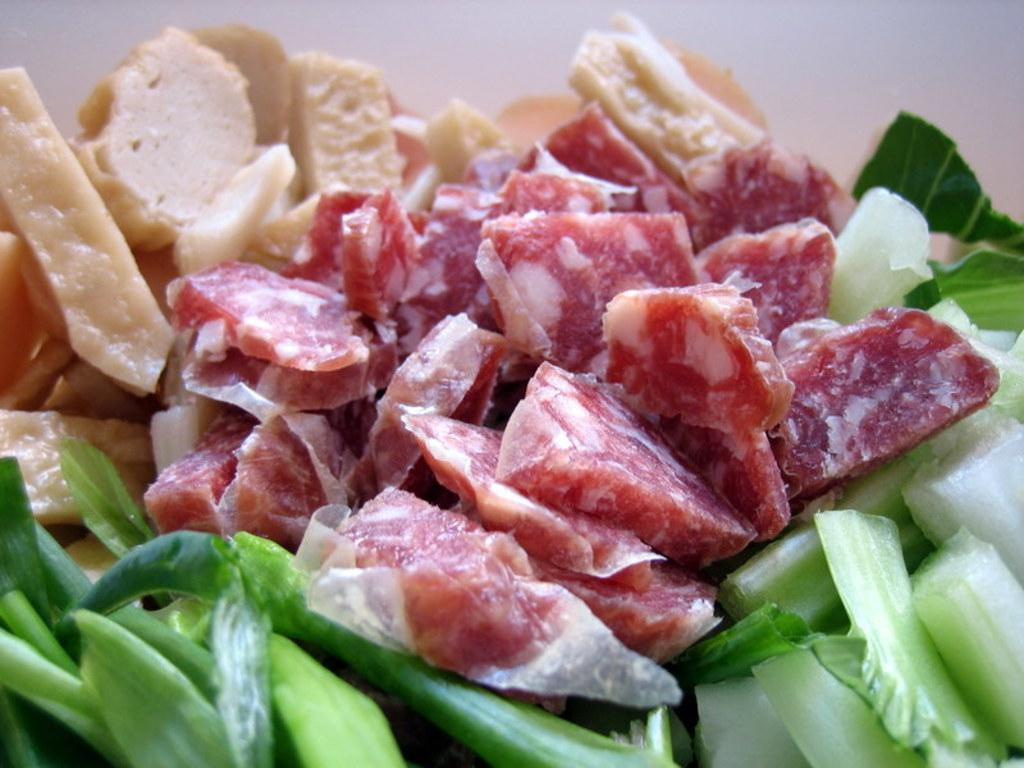What types of food are on the plate in the image? There are meat pieces, vegetable pieces, and other food items on a plate in the image. Can you describe the background of the image? The background of the image is dark in color. What parcel is being offered as a surprise in the image? There is no parcel or surprise present in the image; it only shows a plate of food with meat, vegetable, and other food items. 